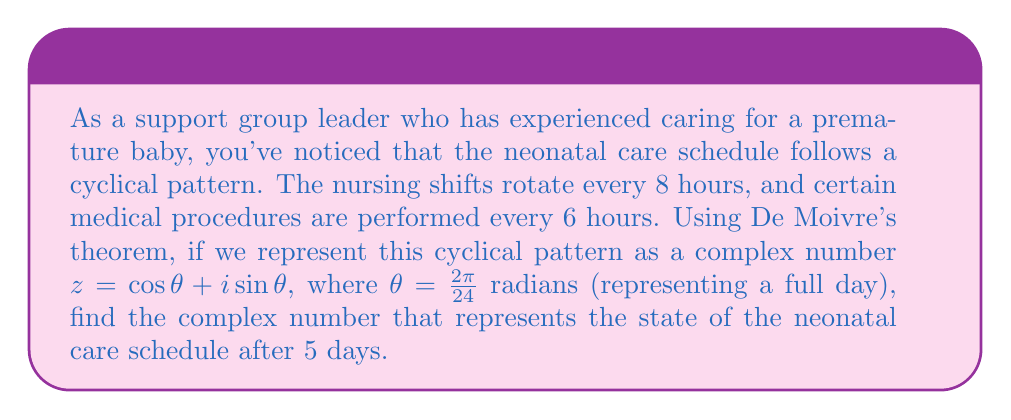Can you solve this math problem? Let's approach this step-by-step:

1) First, we need to understand what De Moivre's theorem states:

   $(\cos \theta + i \sin \theta)^n = \cos(n\theta) + i \sin(n\theta)$

2) In our case, $\theta = \frac{2\pi}{24}$ radians (one full day), and we want to find the state after 5 days, so $n = 5 \times 24 = 120$ (as there are 24 hours in a day).

3) Let's substitute these values into De Moivre's theorem:

   $$(\cos(\frac{2\pi}{24}) + i \sin(\frac{2\pi}{24}))^{120} = \cos(\frac{120 \times 2\pi}{24}) + i \sin(\frac{120 \times 2\pi}{24})$$

4) Simplify the argument of cosine and sine:

   $$\cos(\frac{120 \times 2\pi}{24}) + i \sin(\frac{120 \times 2\pi}{24}) = \cos(10\pi) + i \sin(10\pi)$$

5) Recall that cosine has a period of $2\pi$ and sine has a period of $2\pi$. Therefore:

   $\cos(10\pi) = \cos(0\pi) = 1$
   $\sin(10\pi) = \sin(0\pi) = 0$

6) Thus, our final result is:

   $1 + 0i = 1$

This result indicates that after 5 days, the neonatal care schedule has completed a full cycle and returned to its initial state.
Answer: $1$ 